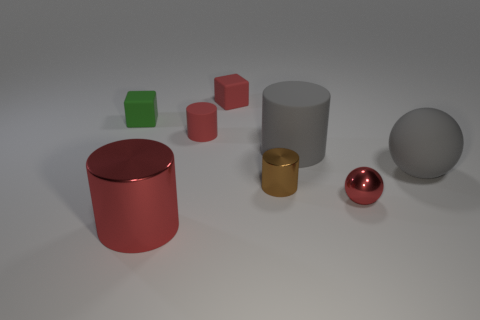Add 2 tiny cyan rubber objects. How many objects exist? 10 Subtract all spheres. How many objects are left? 6 Add 2 red things. How many red things exist? 6 Subtract 0 green cylinders. How many objects are left? 8 Subtract all large gray objects. Subtract all large metallic objects. How many objects are left? 5 Add 2 red rubber things. How many red rubber things are left? 4 